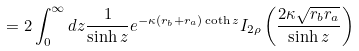Convert formula to latex. <formula><loc_0><loc_0><loc_500><loc_500>= 2 \int _ { 0 } ^ { \infty } d z \frac { 1 } { \sinh z } e ^ { - \kappa ( r _ { b } + r _ { a } ) \coth z } I _ { 2 \rho } \left ( \frac { 2 \kappa \sqrt { r _ { b } r _ { a } } } { \sinh z } \right )</formula> 